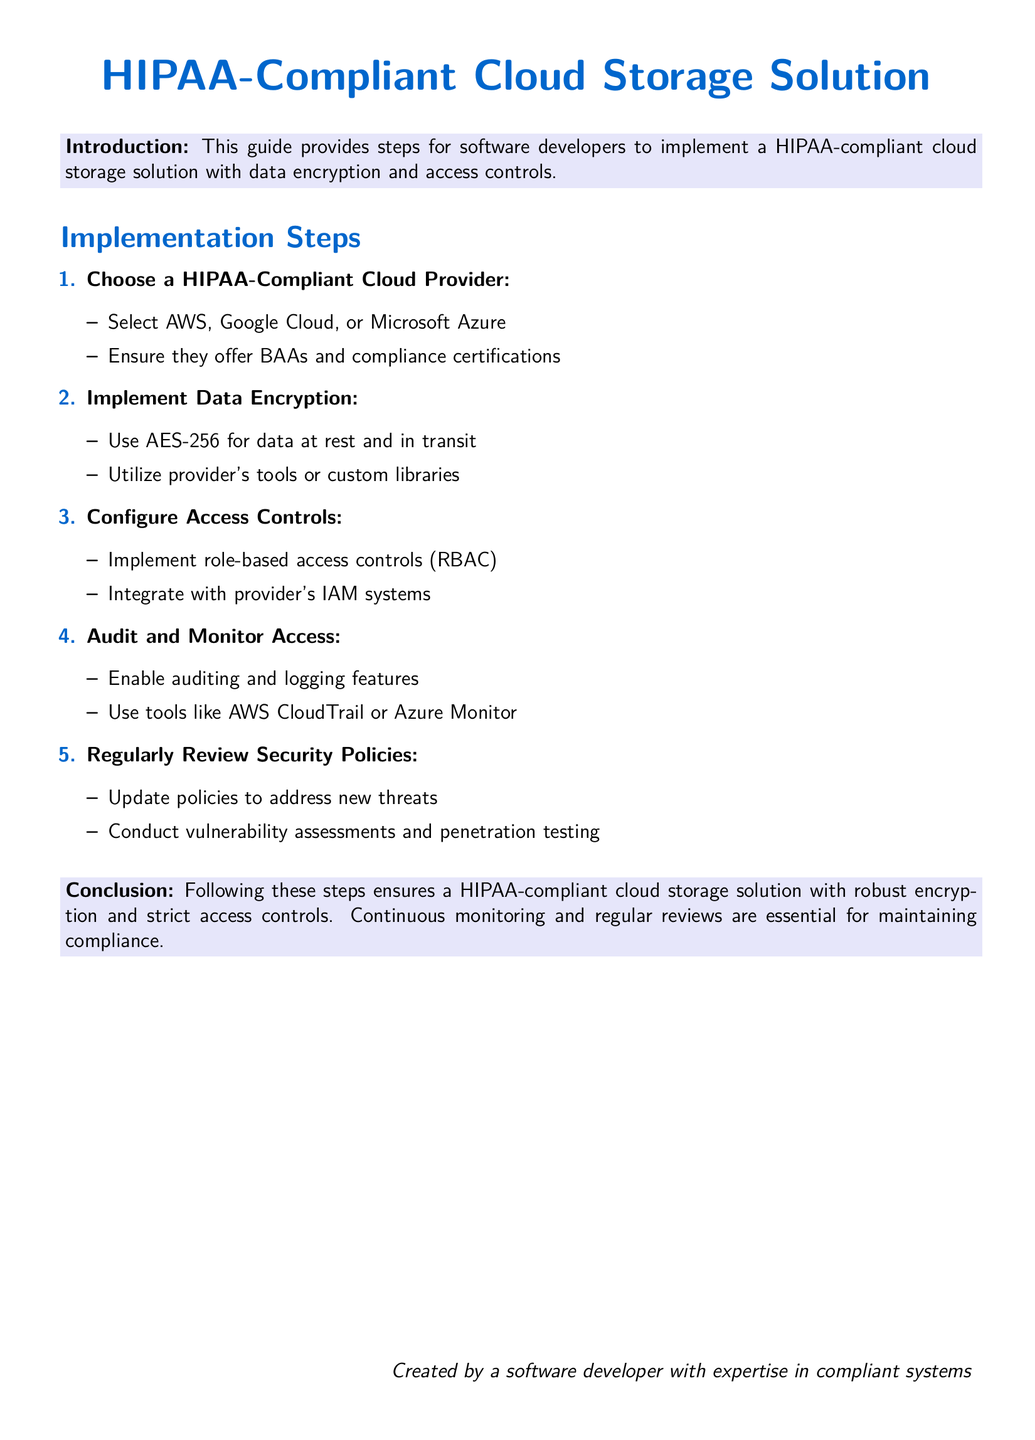What is the main focus of this guide? The main focus is to provide steps for software developers to implement a HIPAA-compliant cloud storage solution with data encryption and access controls.
Answer: Implementing a HIPAA-compliant cloud storage solution with data encryption and access controls Which cloud providers are mentioned as options? The guide mentions AWS, Google Cloud, and Microsoft Azure as HIPAA-compliant cloud providers.
Answer: AWS, Google Cloud, Microsoft Azure What encryption standard is recommended for data? The guide recommends using AES-256 for data encryption.
Answer: AES-256 What type of access control is suggested? The guide suggests implementing role-based access controls (RBAC).
Answer: Role-based access controls (RBAC) What tool is recommended for auditing in AWS? The document recommends using AWS CloudTrail for auditing and monitoring access.
Answer: AWS CloudTrail How many steps are there in the implementation process? The implementation process consists of five steps outlined in the guide.
Answer: Five steps What should be regularly reviewed according to the guide? The guide emphasizes the importance of regularly reviewing security policies to maintain compliance.
Answer: Security policies What is essential for maintaining compliance as per the conclusion? The conclusion states that continuous monitoring and regular reviews are essential for maintaining compliance.
Answer: Continuous monitoring and regular reviews 